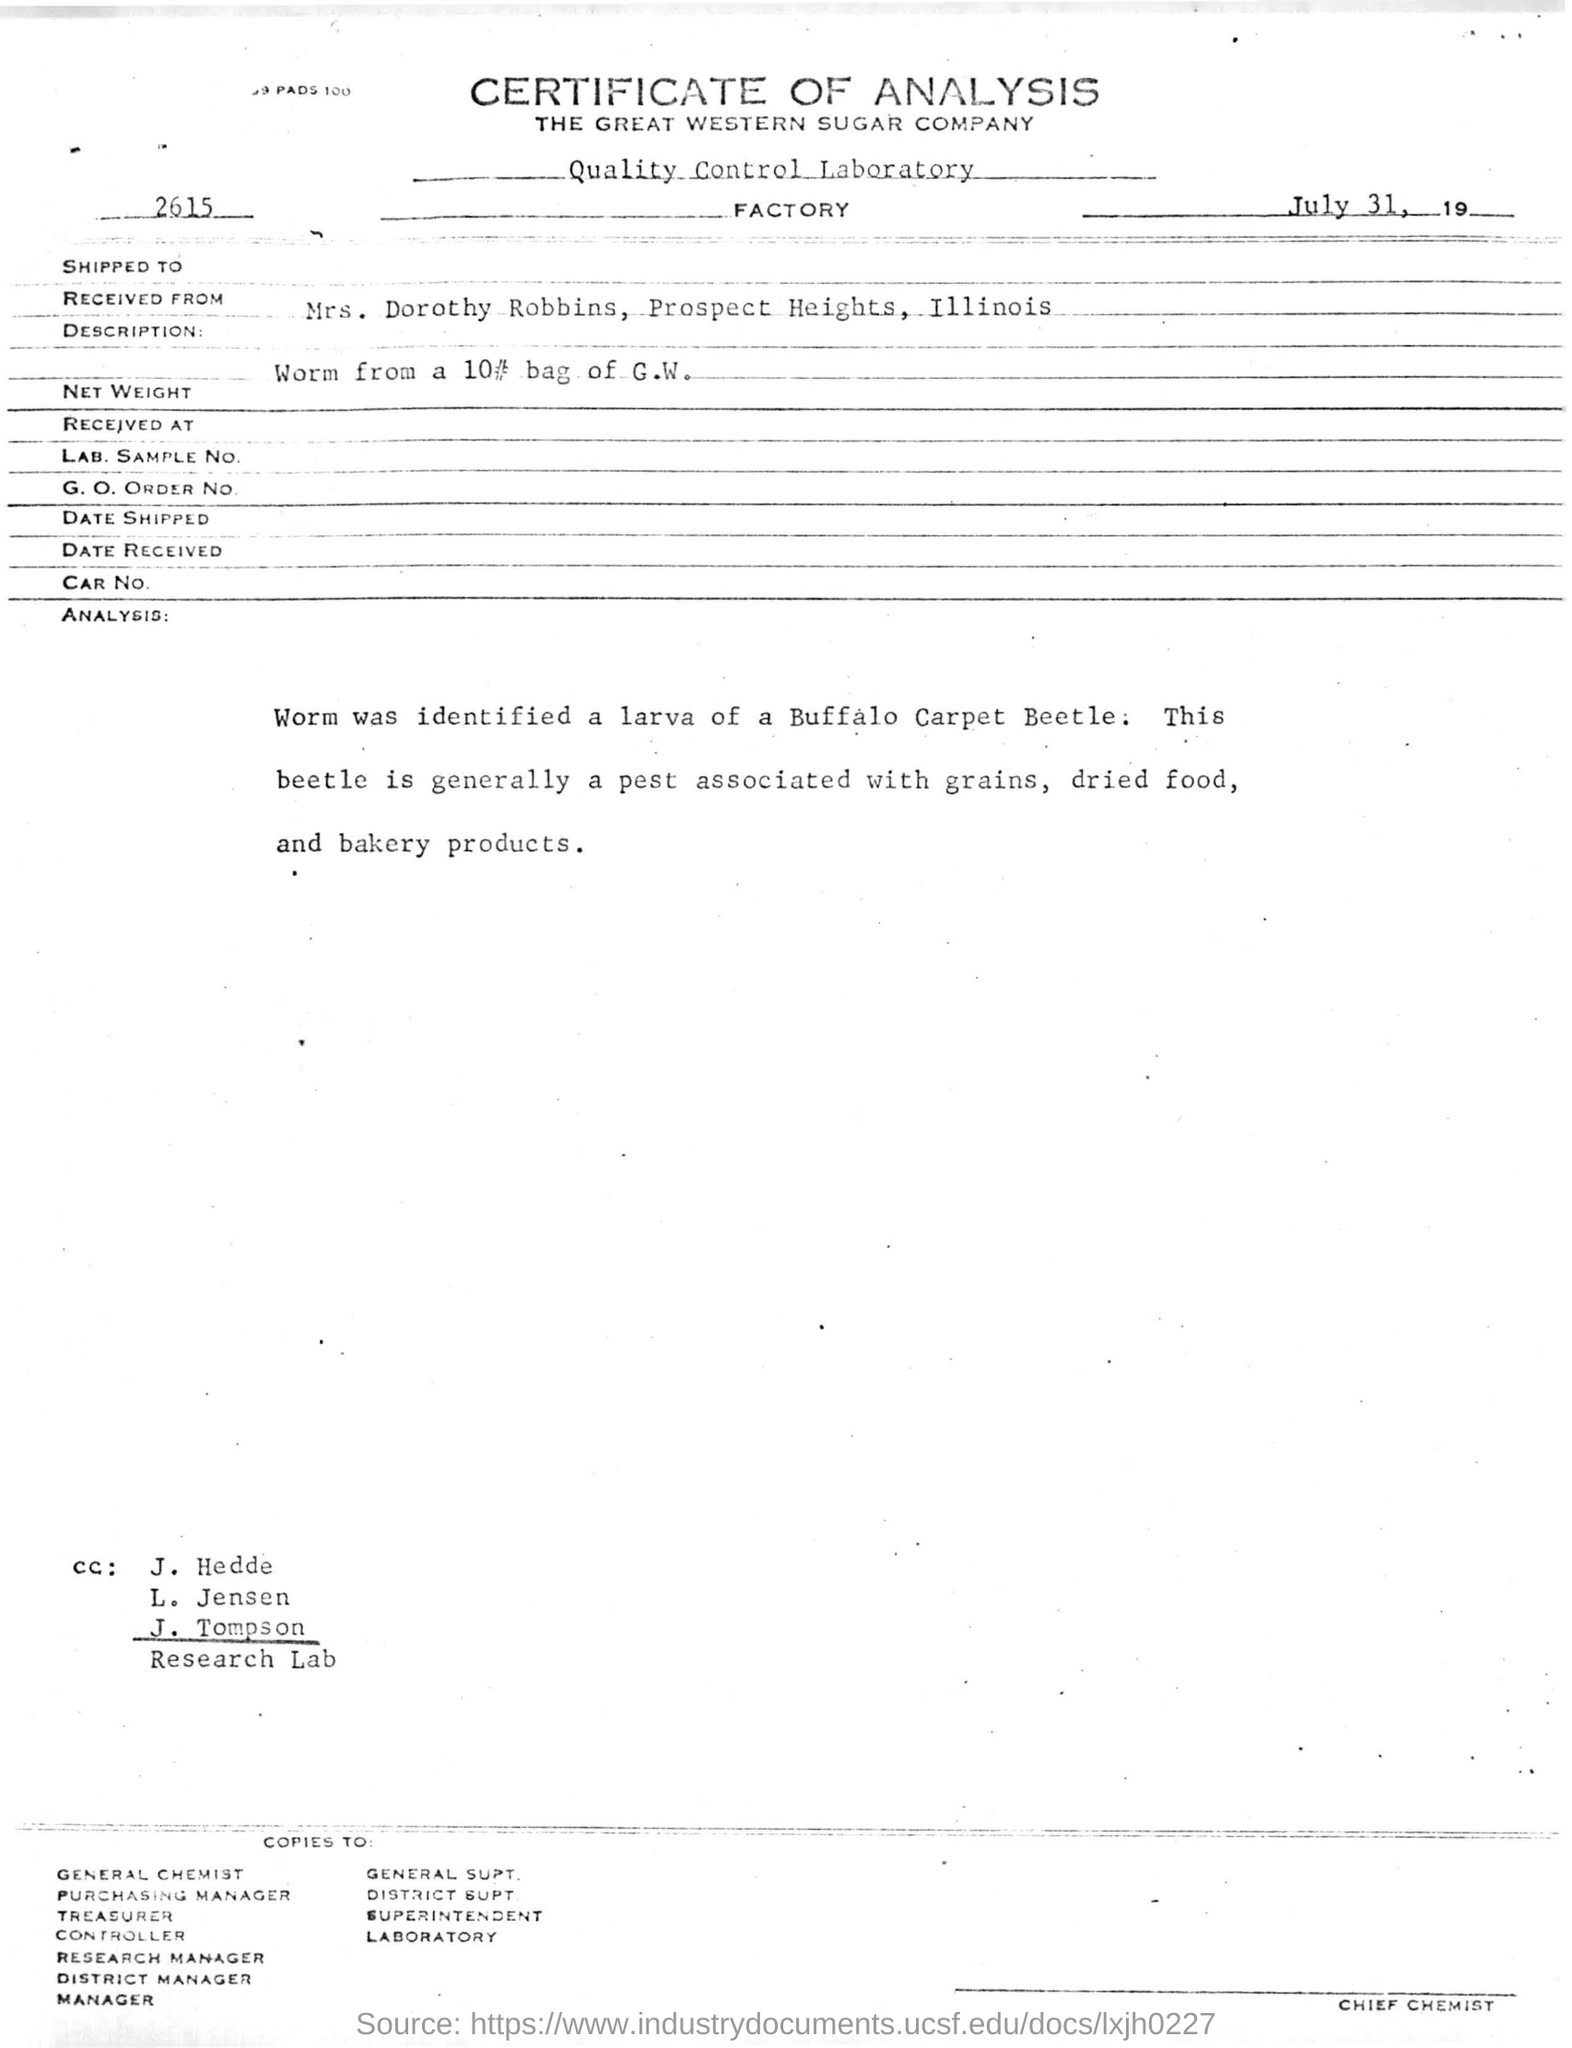Which is the company name mentioned in the letterhead
Provide a short and direct response. The Great Western Sugar Company. Which beetle larva was identified?
Give a very brief answer. Buffalo Carpet Beetle. 